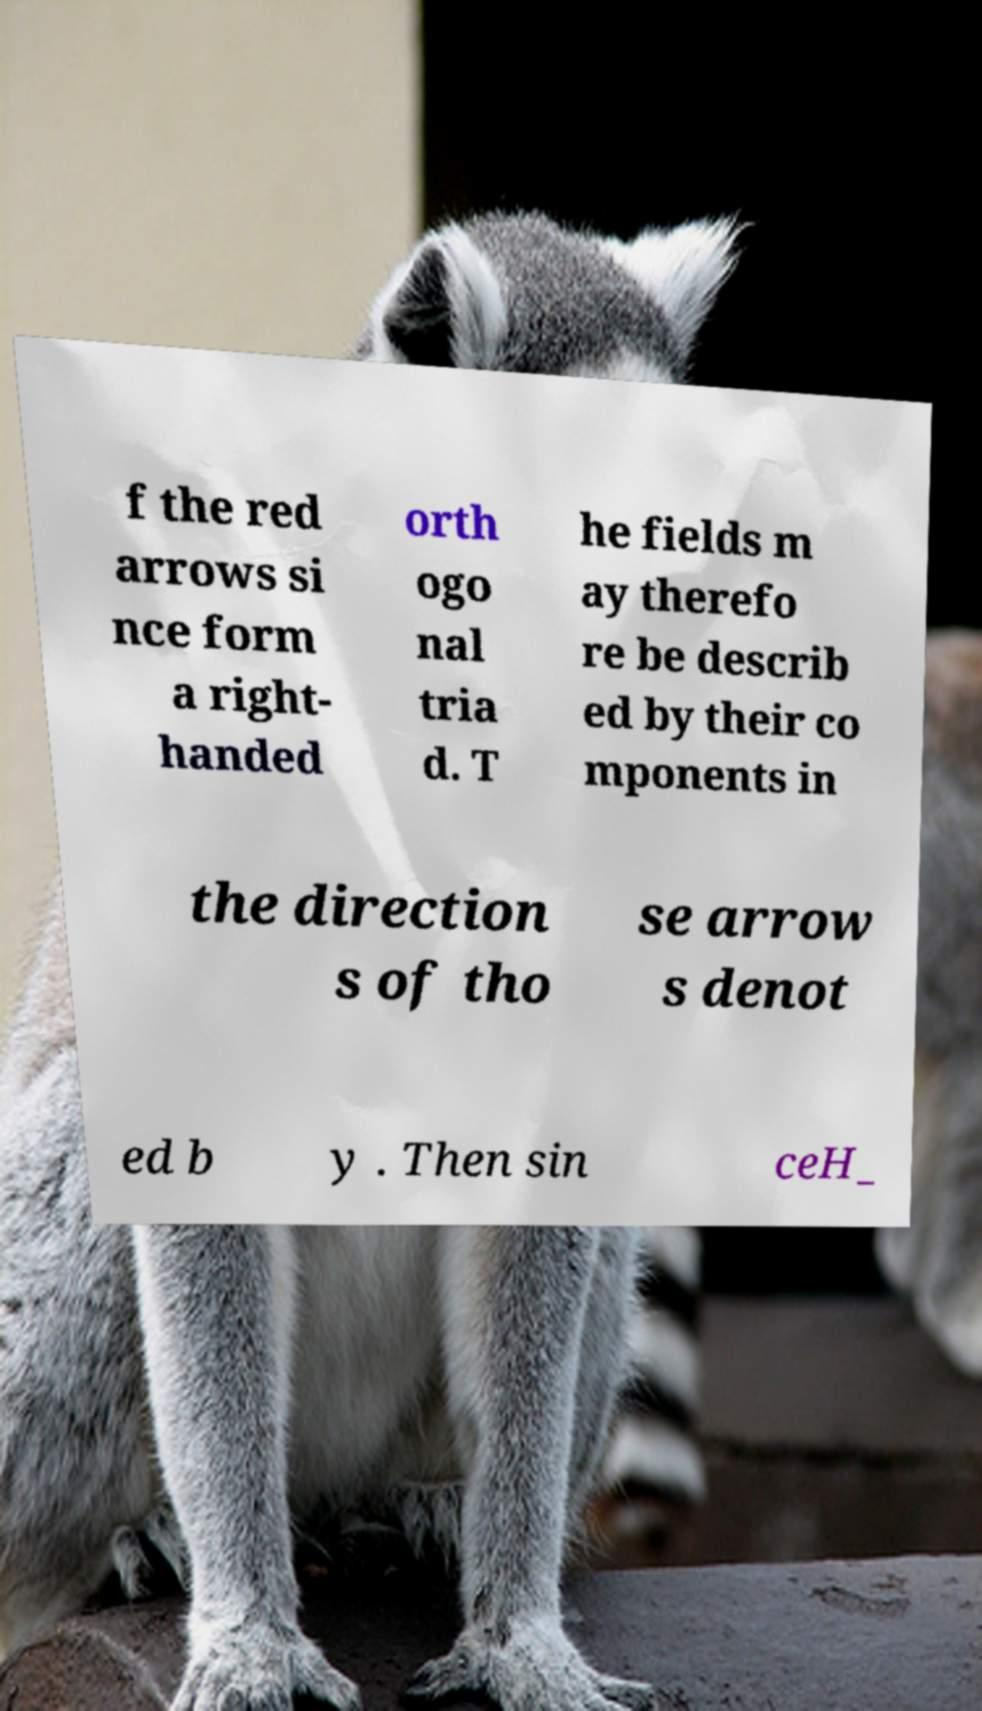Could you extract and type out the text from this image? f the red arrows si nce form a right- handed orth ogo nal tria d. T he fields m ay therefo re be describ ed by their co mponents in the direction s of tho se arrow s denot ed b y . Then sin ceH_ 